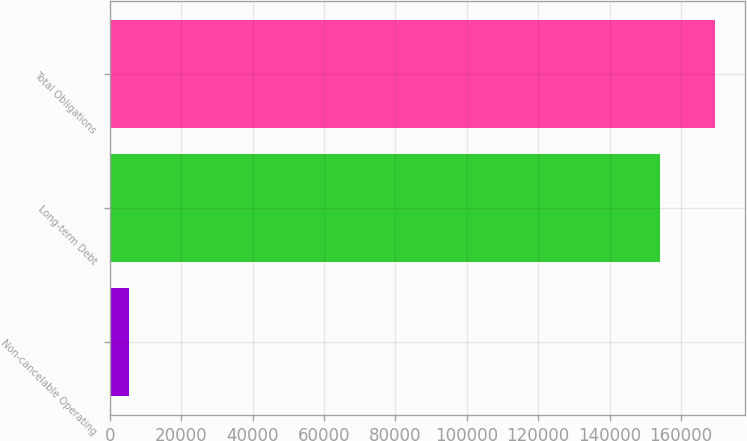<chart> <loc_0><loc_0><loc_500><loc_500><bar_chart><fcel>Non-cancelable Operating<fcel>Long-term Debt<fcel>Total Obligations<nl><fcel>5419<fcel>154103<fcel>169513<nl></chart> 